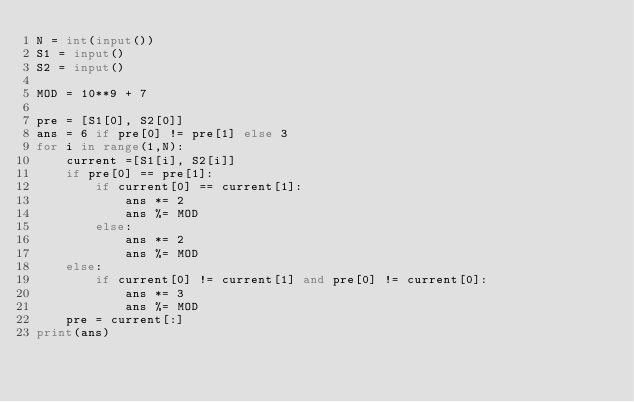<code> <loc_0><loc_0><loc_500><loc_500><_Python_>N = int(input())
S1 = input()
S2 = input()

MOD = 10**9 + 7

pre = [S1[0], S2[0]]
ans = 6 if pre[0] != pre[1] else 3
for i in range(1,N):
    current =[S1[i], S2[i]]
    if pre[0] == pre[1]:
        if current[0] == current[1]:
            ans *= 2
            ans %= MOD
        else:
            ans *= 2
            ans %= MOD
    else:
        if current[0] != current[1] and pre[0] != current[0]:
            ans *= 3
            ans %= MOD
    pre = current[:]
print(ans)</code> 